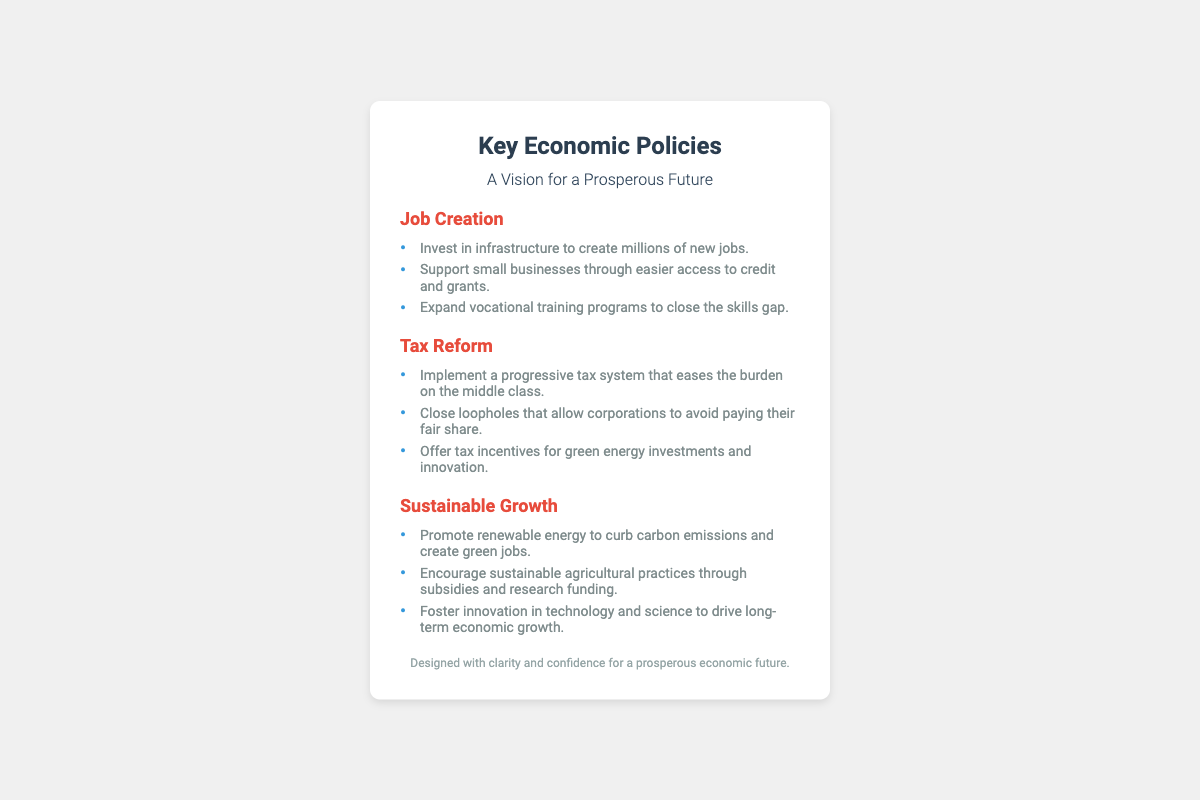What is the title of the document? The title of the document is indicated at the top of the business card.
Answer: Key Economic Policies What is the background color of the business card? The document describes the visual elements, including the background color of the card.
Answer: White What initiative supports small businesses? The document lists various initiatives under the Job Creation section.
Answer: Easier access to credit and grants What type of tax system is proposed? The Tax Reform section outlines the type of tax system being advocated.
Answer: Progressive tax system How many areas are listed under Job Creation? The Job Creation section contains a list of initiatives, and the total number can be counted.
Answer: Three What is the main goal stated for promoting renewable energy? The Sustainable Growth section specifies the aim of promoting renewable energy.
Answer: Curb carbon emissions Which initiative focuses on technology and science? The Sustainable Growth section mentions innovations that drive growth.
Answer: Foster innovation in technology and science What phrase is used to describe the document's design? The footer of the document uses specific wording to characterize its design.
Answer: Clarity and confidence 